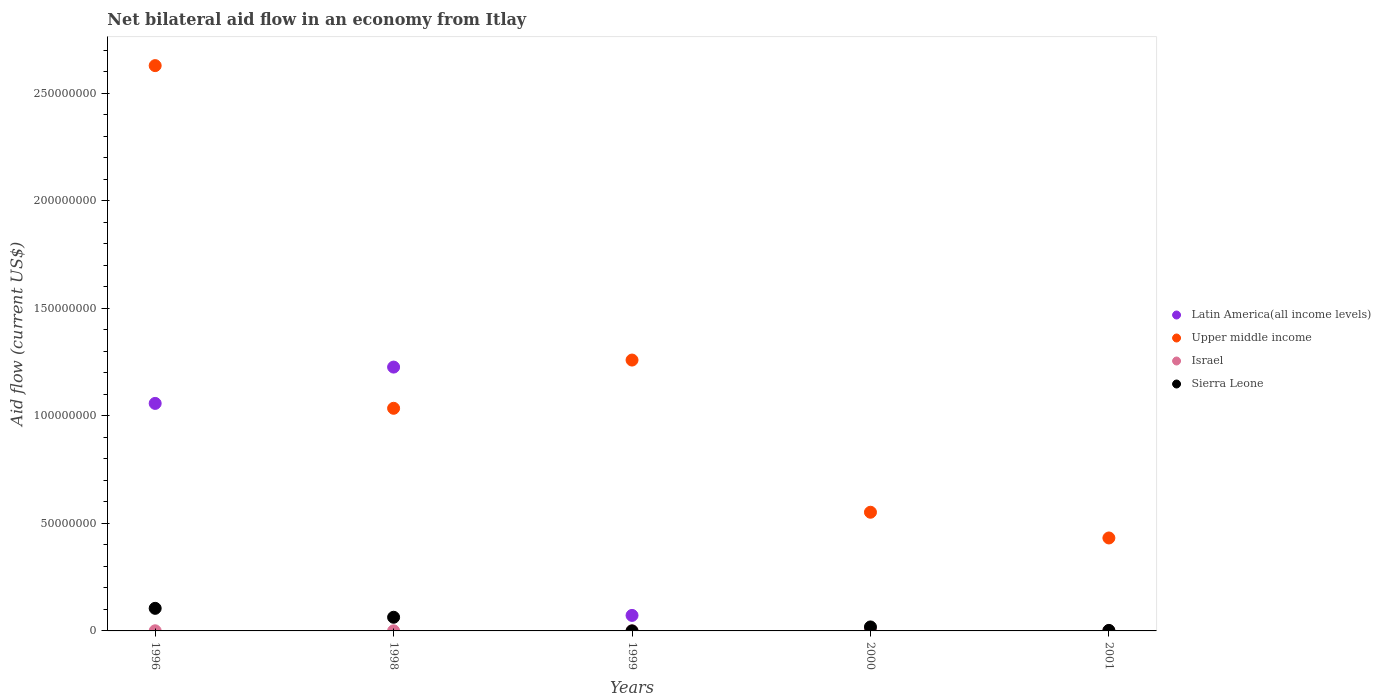How many different coloured dotlines are there?
Keep it short and to the point. 4. What is the net bilateral aid flow in Latin America(all income levels) in 2001?
Provide a short and direct response. 0. Across all years, what is the maximum net bilateral aid flow in Upper middle income?
Your answer should be very brief. 2.63e+08. Across all years, what is the minimum net bilateral aid flow in Upper middle income?
Your answer should be very brief. 4.32e+07. In which year was the net bilateral aid flow in Latin America(all income levels) maximum?
Provide a succinct answer. 1998. What is the total net bilateral aid flow in Latin America(all income levels) in the graph?
Keep it short and to the point. 2.36e+08. What is the difference between the net bilateral aid flow in Sierra Leone in 1998 and that in 1999?
Keep it short and to the point. 6.33e+06. What is the difference between the net bilateral aid flow in Israel in 1998 and the net bilateral aid flow in Sierra Leone in 1996?
Provide a succinct answer. -1.05e+07. What is the average net bilateral aid flow in Upper middle income per year?
Offer a very short reply. 1.18e+08. In the year 2001, what is the difference between the net bilateral aid flow in Upper middle income and net bilateral aid flow in Sierra Leone?
Your response must be concise. 4.30e+07. In how many years, is the net bilateral aid flow in Upper middle income greater than 100000000 US$?
Offer a very short reply. 3. What is the ratio of the net bilateral aid flow in Israel in 2000 to that in 2001?
Ensure brevity in your answer.  2. Is the difference between the net bilateral aid flow in Upper middle income in 1996 and 2001 greater than the difference between the net bilateral aid flow in Sierra Leone in 1996 and 2001?
Offer a very short reply. Yes. What is the difference between the highest and the second highest net bilateral aid flow in Latin America(all income levels)?
Ensure brevity in your answer.  1.69e+07. What is the difference between the highest and the lowest net bilateral aid flow in Latin America(all income levels)?
Give a very brief answer. 1.23e+08. In how many years, is the net bilateral aid flow in Israel greater than the average net bilateral aid flow in Israel taken over all years?
Your response must be concise. 2. Is the sum of the net bilateral aid flow in Upper middle income in 1996 and 1999 greater than the maximum net bilateral aid flow in Latin America(all income levels) across all years?
Your answer should be compact. Yes. How many dotlines are there?
Provide a short and direct response. 4. What is the difference between two consecutive major ticks on the Y-axis?
Keep it short and to the point. 5.00e+07. Where does the legend appear in the graph?
Your response must be concise. Center right. How many legend labels are there?
Provide a short and direct response. 4. What is the title of the graph?
Give a very brief answer. Net bilateral aid flow in an economy from Itlay. Does "Solomon Islands" appear as one of the legend labels in the graph?
Keep it short and to the point. No. What is the label or title of the X-axis?
Make the answer very short. Years. What is the Aid flow (current US$) in Latin America(all income levels) in 1996?
Provide a succinct answer. 1.06e+08. What is the Aid flow (current US$) of Upper middle income in 1996?
Ensure brevity in your answer.  2.63e+08. What is the Aid flow (current US$) of Israel in 1996?
Provide a succinct answer. 6.00e+04. What is the Aid flow (current US$) in Sierra Leone in 1996?
Provide a short and direct response. 1.05e+07. What is the Aid flow (current US$) in Latin America(all income levels) in 1998?
Your answer should be compact. 1.23e+08. What is the Aid flow (current US$) in Upper middle income in 1998?
Provide a short and direct response. 1.03e+08. What is the Aid flow (current US$) of Israel in 1998?
Ensure brevity in your answer.  4.00e+04. What is the Aid flow (current US$) in Sierra Leone in 1998?
Provide a succinct answer. 6.35e+06. What is the Aid flow (current US$) of Latin America(all income levels) in 1999?
Offer a very short reply. 7.21e+06. What is the Aid flow (current US$) of Upper middle income in 1999?
Give a very brief answer. 1.26e+08. What is the Aid flow (current US$) of Israel in 1999?
Offer a very short reply. 10000. What is the Aid flow (current US$) of Upper middle income in 2000?
Provide a succinct answer. 5.52e+07. What is the Aid flow (current US$) in Sierra Leone in 2000?
Your answer should be compact. 1.85e+06. What is the Aid flow (current US$) in Upper middle income in 2001?
Ensure brevity in your answer.  4.32e+07. What is the Aid flow (current US$) of Israel in 2001?
Provide a succinct answer. 3.00e+04. Across all years, what is the maximum Aid flow (current US$) of Latin America(all income levels)?
Provide a short and direct response. 1.23e+08. Across all years, what is the maximum Aid flow (current US$) of Upper middle income?
Give a very brief answer. 2.63e+08. Across all years, what is the maximum Aid flow (current US$) in Sierra Leone?
Provide a short and direct response. 1.05e+07. Across all years, what is the minimum Aid flow (current US$) in Latin America(all income levels)?
Ensure brevity in your answer.  0. Across all years, what is the minimum Aid flow (current US$) of Upper middle income?
Your answer should be very brief. 4.32e+07. Across all years, what is the minimum Aid flow (current US$) in Israel?
Give a very brief answer. 10000. What is the total Aid flow (current US$) in Latin America(all income levels) in the graph?
Offer a terse response. 2.36e+08. What is the total Aid flow (current US$) of Upper middle income in the graph?
Keep it short and to the point. 5.91e+08. What is the total Aid flow (current US$) of Israel in the graph?
Ensure brevity in your answer.  2.00e+05. What is the total Aid flow (current US$) of Sierra Leone in the graph?
Ensure brevity in your answer.  1.90e+07. What is the difference between the Aid flow (current US$) of Latin America(all income levels) in 1996 and that in 1998?
Keep it short and to the point. -1.69e+07. What is the difference between the Aid flow (current US$) of Upper middle income in 1996 and that in 1998?
Keep it short and to the point. 1.59e+08. What is the difference between the Aid flow (current US$) of Israel in 1996 and that in 1998?
Your answer should be very brief. 2.00e+04. What is the difference between the Aid flow (current US$) of Sierra Leone in 1996 and that in 1998?
Provide a succinct answer. 4.15e+06. What is the difference between the Aid flow (current US$) in Latin America(all income levels) in 1996 and that in 1999?
Give a very brief answer. 9.85e+07. What is the difference between the Aid flow (current US$) of Upper middle income in 1996 and that in 1999?
Keep it short and to the point. 1.37e+08. What is the difference between the Aid flow (current US$) in Sierra Leone in 1996 and that in 1999?
Give a very brief answer. 1.05e+07. What is the difference between the Aid flow (current US$) in Upper middle income in 1996 and that in 2000?
Offer a terse response. 2.08e+08. What is the difference between the Aid flow (current US$) of Israel in 1996 and that in 2000?
Your answer should be compact. 0. What is the difference between the Aid flow (current US$) of Sierra Leone in 1996 and that in 2000?
Make the answer very short. 8.65e+06. What is the difference between the Aid flow (current US$) in Upper middle income in 1996 and that in 2001?
Provide a succinct answer. 2.20e+08. What is the difference between the Aid flow (current US$) in Israel in 1996 and that in 2001?
Keep it short and to the point. 3.00e+04. What is the difference between the Aid flow (current US$) in Sierra Leone in 1996 and that in 2001?
Offer a very short reply. 1.03e+07. What is the difference between the Aid flow (current US$) in Latin America(all income levels) in 1998 and that in 1999?
Your answer should be very brief. 1.15e+08. What is the difference between the Aid flow (current US$) of Upper middle income in 1998 and that in 1999?
Your answer should be compact. -2.24e+07. What is the difference between the Aid flow (current US$) of Israel in 1998 and that in 1999?
Offer a very short reply. 3.00e+04. What is the difference between the Aid flow (current US$) of Sierra Leone in 1998 and that in 1999?
Your answer should be compact. 6.33e+06. What is the difference between the Aid flow (current US$) of Upper middle income in 1998 and that in 2000?
Offer a very short reply. 4.83e+07. What is the difference between the Aid flow (current US$) in Sierra Leone in 1998 and that in 2000?
Offer a terse response. 4.50e+06. What is the difference between the Aid flow (current US$) in Upper middle income in 1998 and that in 2001?
Your answer should be very brief. 6.03e+07. What is the difference between the Aid flow (current US$) in Sierra Leone in 1998 and that in 2001?
Offer a terse response. 6.11e+06. What is the difference between the Aid flow (current US$) of Upper middle income in 1999 and that in 2000?
Provide a short and direct response. 7.07e+07. What is the difference between the Aid flow (current US$) of Sierra Leone in 1999 and that in 2000?
Provide a short and direct response. -1.83e+06. What is the difference between the Aid flow (current US$) of Upper middle income in 1999 and that in 2001?
Your answer should be very brief. 8.27e+07. What is the difference between the Aid flow (current US$) of Israel in 1999 and that in 2001?
Your answer should be compact. -2.00e+04. What is the difference between the Aid flow (current US$) of Sierra Leone in 1999 and that in 2001?
Give a very brief answer. -2.20e+05. What is the difference between the Aid flow (current US$) of Upper middle income in 2000 and that in 2001?
Make the answer very short. 1.20e+07. What is the difference between the Aid flow (current US$) of Sierra Leone in 2000 and that in 2001?
Your answer should be compact. 1.61e+06. What is the difference between the Aid flow (current US$) of Latin America(all income levels) in 1996 and the Aid flow (current US$) of Upper middle income in 1998?
Offer a very short reply. 2.27e+06. What is the difference between the Aid flow (current US$) in Latin America(all income levels) in 1996 and the Aid flow (current US$) in Israel in 1998?
Your answer should be compact. 1.06e+08. What is the difference between the Aid flow (current US$) of Latin America(all income levels) in 1996 and the Aid flow (current US$) of Sierra Leone in 1998?
Make the answer very short. 9.94e+07. What is the difference between the Aid flow (current US$) in Upper middle income in 1996 and the Aid flow (current US$) in Israel in 1998?
Offer a terse response. 2.63e+08. What is the difference between the Aid flow (current US$) in Upper middle income in 1996 and the Aid flow (current US$) in Sierra Leone in 1998?
Your answer should be compact. 2.56e+08. What is the difference between the Aid flow (current US$) in Israel in 1996 and the Aid flow (current US$) in Sierra Leone in 1998?
Keep it short and to the point. -6.29e+06. What is the difference between the Aid flow (current US$) of Latin America(all income levels) in 1996 and the Aid flow (current US$) of Upper middle income in 1999?
Your response must be concise. -2.02e+07. What is the difference between the Aid flow (current US$) of Latin America(all income levels) in 1996 and the Aid flow (current US$) of Israel in 1999?
Keep it short and to the point. 1.06e+08. What is the difference between the Aid flow (current US$) in Latin America(all income levels) in 1996 and the Aid flow (current US$) in Sierra Leone in 1999?
Give a very brief answer. 1.06e+08. What is the difference between the Aid flow (current US$) of Upper middle income in 1996 and the Aid flow (current US$) of Israel in 1999?
Your response must be concise. 2.63e+08. What is the difference between the Aid flow (current US$) of Upper middle income in 1996 and the Aid flow (current US$) of Sierra Leone in 1999?
Make the answer very short. 2.63e+08. What is the difference between the Aid flow (current US$) in Israel in 1996 and the Aid flow (current US$) in Sierra Leone in 1999?
Your answer should be very brief. 4.00e+04. What is the difference between the Aid flow (current US$) of Latin America(all income levels) in 1996 and the Aid flow (current US$) of Upper middle income in 2000?
Ensure brevity in your answer.  5.06e+07. What is the difference between the Aid flow (current US$) of Latin America(all income levels) in 1996 and the Aid flow (current US$) of Israel in 2000?
Give a very brief answer. 1.06e+08. What is the difference between the Aid flow (current US$) in Latin America(all income levels) in 1996 and the Aid flow (current US$) in Sierra Leone in 2000?
Make the answer very short. 1.04e+08. What is the difference between the Aid flow (current US$) in Upper middle income in 1996 and the Aid flow (current US$) in Israel in 2000?
Offer a very short reply. 2.63e+08. What is the difference between the Aid flow (current US$) of Upper middle income in 1996 and the Aid flow (current US$) of Sierra Leone in 2000?
Your answer should be very brief. 2.61e+08. What is the difference between the Aid flow (current US$) of Israel in 1996 and the Aid flow (current US$) of Sierra Leone in 2000?
Give a very brief answer. -1.79e+06. What is the difference between the Aid flow (current US$) of Latin America(all income levels) in 1996 and the Aid flow (current US$) of Upper middle income in 2001?
Provide a succinct answer. 6.26e+07. What is the difference between the Aid flow (current US$) in Latin America(all income levels) in 1996 and the Aid flow (current US$) in Israel in 2001?
Your answer should be compact. 1.06e+08. What is the difference between the Aid flow (current US$) of Latin America(all income levels) in 1996 and the Aid flow (current US$) of Sierra Leone in 2001?
Keep it short and to the point. 1.06e+08. What is the difference between the Aid flow (current US$) in Upper middle income in 1996 and the Aid flow (current US$) in Israel in 2001?
Provide a succinct answer. 2.63e+08. What is the difference between the Aid flow (current US$) in Upper middle income in 1996 and the Aid flow (current US$) in Sierra Leone in 2001?
Provide a short and direct response. 2.63e+08. What is the difference between the Aid flow (current US$) of Latin America(all income levels) in 1998 and the Aid flow (current US$) of Upper middle income in 1999?
Make the answer very short. -3.27e+06. What is the difference between the Aid flow (current US$) of Latin America(all income levels) in 1998 and the Aid flow (current US$) of Israel in 1999?
Keep it short and to the point. 1.23e+08. What is the difference between the Aid flow (current US$) of Latin America(all income levels) in 1998 and the Aid flow (current US$) of Sierra Leone in 1999?
Make the answer very short. 1.23e+08. What is the difference between the Aid flow (current US$) in Upper middle income in 1998 and the Aid flow (current US$) in Israel in 1999?
Offer a very short reply. 1.03e+08. What is the difference between the Aid flow (current US$) in Upper middle income in 1998 and the Aid flow (current US$) in Sierra Leone in 1999?
Keep it short and to the point. 1.03e+08. What is the difference between the Aid flow (current US$) of Israel in 1998 and the Aid flow (current US$) of Sierra Leone in 1999?
Provide a succinct answer. 2.00e+04. What is the difference between the Aid flow (current US$) in Latin America(all income levels) in 1998 and the Aid flow (current US$) in Upper middle income in 2000?
Offer a very short reply. 6.75e+07. What is the difference between the Aid flow (current US$) in Latin America(all income levels) in 1998 and the Aid flow (current US$) in Israel in 2000?
Your response must be concise. 1.23e+08. What is the difference between the Aid flow (current US$) in Latin America(all income levels) in 1998 and the Aid flow (current US$) in Sierra Leone in 2000?
Provide a short and direct response. 1.21e+08. What is the difference between the Aid flow (current US$) in Upper middle income in 1998 and the Aid flow (current US$) in Israel in 2000?
Keep it short and to the point. 1.03e+08. What is the difference between the Aid flow (current US$) of Upper middle income in 1998 and the Aid flow (current US$) of Sierra Leone in 2000?
Offer a terse response. 1.02e+08. What is the difference between the Aid flow (current US$) in Israel in 1998 and the Aid flow (current US$) in Sierra Leone in 2000?
Keep it short and to the point. -1.81e+06. What is the difference between the Aid flow (current US$) of Latin America(all income levels) in 1998 and the Aid flow (current US$) of Upper middle income in 2001?
Provide a succinct answer. 7.94e+07. What is the difference between the Aid flow (current US$) in Latin America(all income levels) in 1998 and the Aid flow (current US$) in Israel in 2001?
Keep it short and to the point. 1.23e+08. What is the difference between the Aid flow (current US$) of Latin America(all income levels) in 1998 and the Aid flow (current US$) of Sierra Leone in 2001?
Keep it short and to the point. 1.22e+08. What is the difference between the Aid flow (current US$) in Upper middle income in 1998 and the Aid flow (current US$) in Israel in 2001?
Give a very brief answer. 1.03e+08. What is the difference between the Aid flow (current US$) of Upper middle income in 1998 and the Aid flow (current US$) of Sierra Leone in 2001?
Give a very brief answer. 1.03e+08. What is the difference between the Aid flow (current US$) in Latin America(all income levels) in 1999 and the Aid flow (current US$) in Upper middle income in 2000?
Ensure brevity in your answer.  -4.80e+07. What is the difference between the Aid flow (current US$) of Latin America(all income levels) in 1999 and the Aid flow (current US$) of Israel in 2000?
Give a very brief answer. 7.15e+06. What is the difference between the Aid flow (current US$) of Latin America(all income levels) in 1999 and the Aid flow (current US$) of Sierra Leone in 2000?
Provide a succinct answer. 5.36e+06. What is the difference between the Aid flow (current US$) in Upper middle income in 1999 and the Aid flow (current US$) in Israel in 2000?
Provide a succinct answer. 1.26e+08. What is the difference between the Aid flow (current US$) in Upper middle income in 1999 and the Aid flow (current US$) in Sierra Leone in 2000?
Your response must be concise. 1.24e+08. What is the difference between the Aid flow (current US$) in Israel in 1999 and the Aid flow (current US$) in Sierra Leone in 2000?
Offer a very short reply. -1.84e+06. What is the difference between the Aid flow (current US$) of Latin America(all income levels) in 1999 and the Aid flow (current US$) of Upper middle income in 2001?
Offer a very short reply. -3.60e+07. What is the difference between the Aid flow (current US$) in Latin America(all income levels) in 1999 and the Aid flow (current US$) in Israel in 2001?
Your answer should be very brief. 7.18e+06. What is the difference between the Aid flow (current US$) in Latin America(all income levels) in 1999 and the Aid flow (current US$) in Sierra Leone in 2001?
Your answer should be very brief. 6.97e+06. What is the difference between the Aid flow (current US$) in Upper middle income in 1999 and the Aid flow (current US$) in Israel in 2001?
Offer a very short reply. 1.26e+08. What is the difference between the Aid flow (current US$) in Upper middle income in 1999 and the Aid flow (current US$) in Sierra Leone in 2001?
Your answer should be compact. 1.26e+08. What is the difference between the Aid flow (current US$) of Upper middle income in 2000 and the Aid flow (current US$) of Israel in 2001?
Make the answer very short. 5.51e+07. What is the difference between the Aid flow (current US$) in Upper middle income in 2000 and the Aid flow (current US$) in Sierra Leone in 2001?
Ensure brevity in your answer.  5.49e+07. What is the difference between the Aid flow (current US$) in Israel in 2000 and the Aid flow (current US$) in Sierra Leone in 2001?
Offer a terse response. -1.80e+05. What is the average Aid flow (current US$) of Latin America(all income levels) per year?
Offer a terse response. 4.71e+07. What is the average Aid flow (current US$) in Upper middle income per year?
Make the answer very short. 1.18e+08. What is the average Aid flow (current US$) of Israel per year?
Give a very brief answer. 4.00e+04. What is the average Aid flow (current US$) of Sierra Leone per year?
Keep it short and to the point. 3.79e+06. In the year 1996, what is the difference between the Aid flow (current US$) in Latin America(all income levels) and Aid flow (current US$) in Upper middle income?
Ensure brevity in your answer.  -1.57e+08. In the year 1996, what is the difference between the Aid flow (current US$) of Latin America(all income levels) and Aid flow (current US$) of Israel?
Offer a terse response. 1.06e+08. In the year 1996, what is the difference between the Aid flow (current US$) in Latin America(all income levels) and Aid flow (current US$) in Sierra Leone?
Your answer should be compact. 9.53e+07. In the year 1996, what is the difference between the Aid flow (current US$) of Upper middle income and Aid flow (current US$) of Israel?
Give a very brief answer. 2.63e+08. In the year 1996, what is the difference between the Aid flow (current US$) of Upper middle income and Aid flow (current US$) of Sierra Leone?
Your response must be concise. 2.52e+08. In the year 1996, what is the difference between the Aid flow (current US$) of Israel and Aid flow (current US$) of Sierra Leone?
Offer a very short reply. -1.04e+07. In the year 1998, what is the difference between the Aid flow (current US$) of Latin America(all income levels) and Aid flow (current US$) of Upper middle income?
Offer a terse response. 1.92e+07. In the year 1998, what is the difference between the Aid flow (current US$) in Latin America(all income levels) and Aid flow (current US$) in Israel?
Your response must be concise. 1.23e+08. In the year 1998, what is the difference between the Aid flow (current US$) of Latin America(all income levels) and Aid flow (current US$) of Sierra Leone?
Ensure brevity in your answer.  1.16e+08. In the year 1998, what is the difference between the Aid flow (current US$) of Upper middle income and Aid flow (current US$) of Israel?
Provide a short and direct response. 1.03e+08. In the year 1998, what is the difference between the Aid flow (current US$) of Upper middle income and Aid flow (current US$) of Sierra Leone?
Provide a succinct answer. 9.71e+07. In the year 1998, what is the difference between the Aid flow (current US$) of Israel and Aid flow (current US$) of Sierra Leone?
Provide a short and direct response. -6.31e+06. In the year 1999, what is the difference between the Aid flow (current US$) in Latin America(all income levels) and Aid flow (current US$) in Upper middle income?
Ensure brevity in your answer.  -1.19e+08. In the year 1999, what is the difference between the Aid flow (current US$) of Latin America(all income levels) and Aid flow (current US$) of Israel?
Offer a very short reply. 7.20e+06. In the year 1999, what is the difference between the Aid flow (current US$) of Latin America(all income levels) and Aid flow (current US$) of Sierra Leone?
Your answer should be very brief. 7.19e+06. In the year 1999, what is the difference between the Aid flow (current US$) in Upper middle income and Aid flow (current US$) in Israel?
Give a very brief answer. 1.26e+08. In the year 1999, what is the difference between the Aid flow (current US$) of Upper middle income and Aid flow (current US$) of Sierra Leone?
Your response must be concise. 1.26e+08. In the year 1999, what is the difference between the Aid flow (current US$) of Israel and Aid flow (current US$) of Sierra Leone?
Provide a short and direct response. -10000. In the year 2000, what is the difference between the Aid flow (current US$) of Upper middle income and Aid flow (current US$) of Israel?
Give a very brief answer. 5.51e+07. In the year 2000, what is the difference between the Aid flow (current US$) of Upper middle income and Aid flow (current US$) of Sierra Leone?
Provide a short and direct response. 5.33e+07. In the year 2000, what is the difference between the Aid flow (current US$) in Israel and Aid flow (current US$) in Sierra Leone?
Provide a short and direct response. -1.79e+06. In the year 2001, what is the difference between the Aid flow (current US$) of Upper middle income and Aid flow (current US$) of Israel?
Give a very brief answer. 4.32e+07. In the year 2001, what is the difference between the Aid flow (current US$) in Upper middle income and Aid flow (current US$) in Sierra Leone?
Give a very brief answer. 4.30e+07. What is the ratio of the Aid flow (current US$) in Latin America(all income levels) in 1996 to that in 1998?
Your answer should be compact. 0.86. What is the ratio of the Aid flow (current US$) of Upper middle income in 1996 to that in 1998?
Keep it short and to the point. 2.54. What is the ratio of the Aid flow (current US$) of Sierra Leone in 1996 to that in 1998?
Your response must be concise. 1.65. What is the ratio of the Aid flow (current US$) in Latin America(all income levels) in 1996 to that in 1999?
Provide a short and direct response. 14.67. What is the ratio of the Aid flow (current US$) of Upper middle income in 1996 to that in 1999?
Provide a short and direct response. 2.09. What is the ratio of the Aid flow (current US$) in Israel in 1996 to that in 1999?
Keep it short and to the point. 6. What is the ratio of the Aid flow (current US$) of Sierra Leone in 1996 to that in 1999?
Offer a terse response. 525. What is the ratio of the Aid flow (current US$) of Upper middle income in 1996 to that in 2000?
Keep it short and to the point. 4.76. What is the ratio of the Aid flow (current US$) of Sierra Leone in 1996 to that in 2000?
Provide a succinct answer. 5.68. What is the ratio of the Aid flow (current US$) in Upper middle income in 1996 to that in 2001?
Your answer should be very brief. 6.08. What is the ratio of the Aid flow (current US$) of Israel in 1996 to that in 2001?
Offer a terse response. 2. What is the ratio of the Aid flow (current US$) of Sierra Leone in 1996 to that in 2001?
Offer a terse response. 43.75. What is the ratio of the Aid flow (current US$) of Latin America(all income levels) in 1998 to that in 1999?
Provide a short and direct response. 17.01. What is the ratio of the Aid flow (current US$) in Upper middle income in 1998 to that in 1999?
Offer a very short reply. 0.82. What is the ratio of the Aid flow (current US$) of Sierra Leone in 1998 to that in 1999?
Make the answer very short. 317.5. What is the ratio of the Aid flow (current US$) in Upper middle income in 1998 to that in 2000?
Offer a very short reply. 1.88. What is the ratio of the Aid flow (current US$) in Sierra Leone in 1998 to that in 2000?
Keep it short and to the point. 3.43. What is the ratio of the Aid flow (current US$) of Upper middle income in 1998 to that in 2001?
Provide a succinct answer. 2.4. What is the ratio of the Aid flow (current US$) of Sierra Leone in 1998 to that in 2001?
Offer a very short reply. 26.46. What is the ratio of the Aid flow (current US$) in Upper middle income in 1999 to that in 2000?
Your response must be concise. 2.28. What is the ratio of the Aid flow (current US$) of Israel in 1999 to that in 2000?
Keep it short and to the point. 0.17. What is the ratio of the Aid flow (current US$) in Sierra Leone in 1999 to that in 2000?
Give a very brief answer. 0.01. What is the ratio of the Aid flow (current US$) in Upper middle income in 1999 to that in 2001?
Keep it short and to the point. 2.91. What is the ratio of the Aid flow (current US$) in Sierra Leone in 1999 to that in 2001?
Offer a terse response. 0.08. What is the ratio of the Aid flow (current US$) in Upper middle income in 2000 to that in 2001?
Your response must be concise. 1.28. What is the ratio of the Aid flow (current US$) in Sierra Leone in 2000 to that in 2001?
Your response must be concise. 7.71. What is the difference between the highest and the second highest Aid flow (current US$) of Latin America(all income levels)?
Your answer should be very brief. 1.69e+07. What is the difference between the highest and the second highest Aid flow (current US$) of Upper middle income?
Provide a succinct answer. 1.37e+08. What is the difference between the highest and the second highest Aid flow (current US$) of Sierra Leone?
Provide a short and direct response. 4.15e+06. What is the difference between the highest and the lowest Aid flow (current US$) of Latin America(all income levels)?
Offer a terse response. 1.23e+08. What is the difference between the highest and the lowest Aid flow (current US$) of Upper middle income?
Provide a succinct answer. 2.20e+08. What is the difference between the highest and the lowest Aid flow (current US$) in Sierra Leone?
Ensure brevity in your answer.  1.05e+07. 